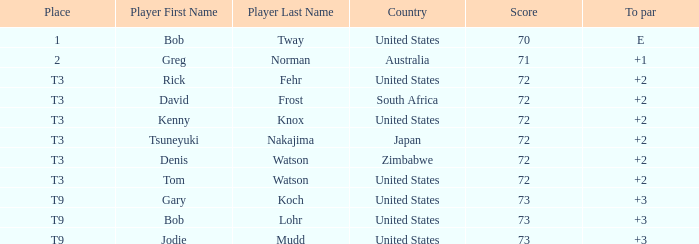What is the top score for tsuneyuki nakajima? 72.0. Would you mind parsing the complete table? {'header': ['Place', 'Player First Name', 'Player Last Name', 'Country', 'Score', 'To par'], 'rows': [['1', 'Bob', 'Tway', 'United States', '70', 'E'], ['2', 'Greg', 'Norman', 'Australia', '71', '+1'], ['T3', 'Rick', 'Fehr', 'United States', '72', '+2'], ['T3', 'David', 'Frost', 'South Africa', '72', '+2'], ['T3', 'Kenny', 'Knox', 'United States', '72', '+2'], ['T3', 'Tsuneyuki', 'Nakajima', 'Japan', '72', '+2'], ['T3', 'Denis', 'Watson', 'Zimbabwe', '72', '+2'], ['T3', 'Tom', 'Watson', 'United States', '72', '+2'], ['T9', 'Gary', 'Koch', 'United States', '73', '+3'], ['T9', 'Bob', 'Lohr', 'United States', '73', '+3'], ['T9', 'Jodie', 'Mudd', 'United States', '73', '+3']]} 